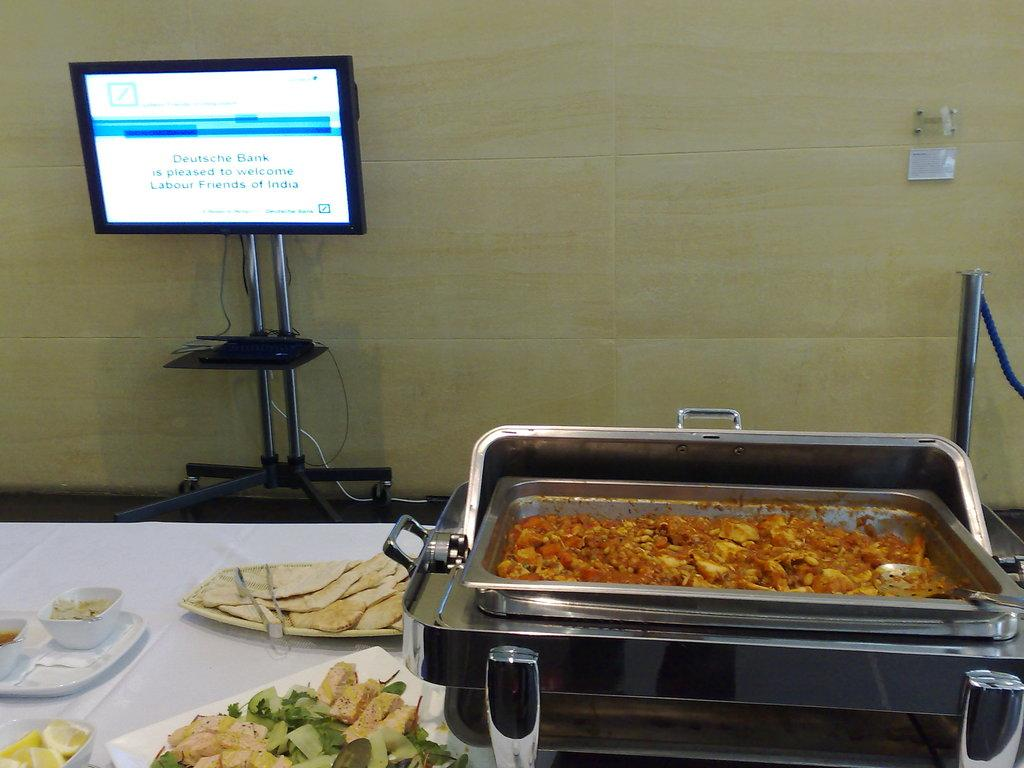<image>
Provide a brief description of the given image. Deutsche Bank is hosting a banquet with food on the table. 